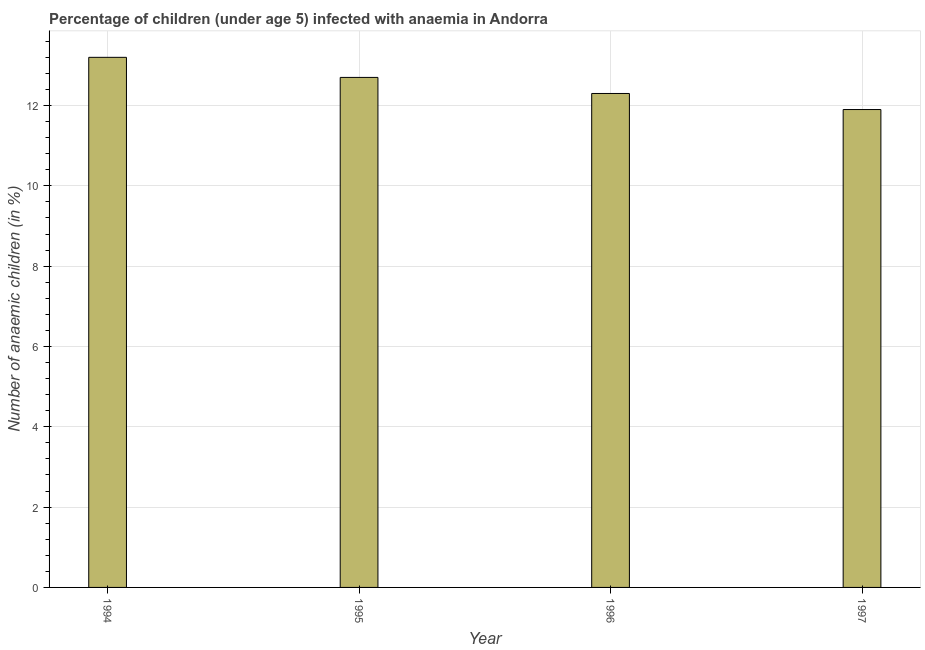Does the graph contain grids?
Ensure brevity in your answer.  Yes. What is the title of the graph?
Your answer should be very brief. Percentage of children (under age 5) infected with anaemia in Andorra. What is the label or title of the X-axis?
Offer a very short reply. Year. What is the label or title of the Y-axis?
Provide a succinct answer. Number of anaemic children (in %). Across all years, what is the maximum number of anaemic children?
Provide a short and direct response. 13.2. Across all years, what is the minimum number of anaemic children?
Offer a very short reply. 11.9. In which year was the number of anaemic children maximum?
Your answer should be compact. 1994. What is the sum of the number of anaemic children?
Ensure brevity in your answer.  50.1. What is the average number of anaemic children per year?
Offer a very short reply. 12.53. What is the ratio of the number of anaemic children in 1995 to that in 1996?
Your response must be concise. 1.03. Is the number of anaemic children in 1994 less than that in 1997?
Your answer should be very brief. No. Is the difference between the number of anaemic children in 1995 and 1997 greater than the difference between any two years?
Your answer should be very brief. No. What is the difference between the highest and the second highest number of anaemic children?
Offer a terse response. 0.5. How many bars are there?
Your response must be concise. 4. What is the Number of anaemic children (in %) in 1995?
Your response must be concise. 12.7. What is the Number of anaemic children (in %) in 1997?
Offer a very short reply. 11.9. What is the difference between the Number of anaemic children (in %) in 1994 and 1997?
Make the answer very short. 1.3. What is the difference between the Number of anaemic children (in %) in 1995 and 1996?
Your response must be concise. 0.4. What is the difference between the Number of anaemic children (in %) in 1995 and 1997?
Give a very brief answer. 0.8. What is the ratio of the Number of anaemic children (in %) in 1994 to that in 1995?
Provide a short and direct response. 1.04. What is the ratio of the Number of anaemic children (in %) in 1994 to that in 1996?
Give a very brief answer. 1.07. What is the ratio of the Number of anaemic children (in %) in 1994 to that in 1997?
Your answer should be very brief. 1.11. What is the ratio of the Number of anaemic children (in %) in 1995 to that in 1996?
Make the answer very short. 1.03. What is the ratio of the Number of anaemic children (in %) in 1995 to that in 1997?
Offer a very short reply. 1.07. What is the ratio of the Number of anaemic children (in %) in 1996 to that in 1997?
Give a very brief answer. 1.03. 